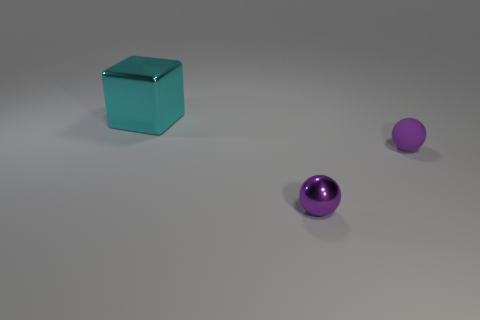There is a object in front of the purple matte sphere; does it have the same color as the rubber object?
Ensure brevity in your answer.  Yes. Do the purple matte ball and the metallic block have the same size?
Offer a terse response. No. There is a purple shiny thing that is the same size as the matte object; what is its shape?
Your answer should be compact. Sphere. Do the purple sphere that is to the right of the purple metal thing and the purple shiny sphere have the same size?
Your answer should be very brief. Yes. There is a purple sphere that is the same size as the purple matte object; what is its material?
Provide a succinct answer. Metal. There is a thing that is on the right side of the tiny purple ball that is to the left of the small purple matte thing; is there a small purple metallic ball right of it?
Your response must be concise. No. Are there any other things that are the same shape as the large cyan shiny thing?
Your answer should be compact. No. There is a metal object to the right of the block; is it the same color as the shiny thing that is behind the shiny sphere?
Offer a terse response. No. Is there a large cyan metallic thing?
Give a very brief answer. Yes. There is another object that is the same color as the matte thing; what material is it?
Provide a short and direct response. Metal. 